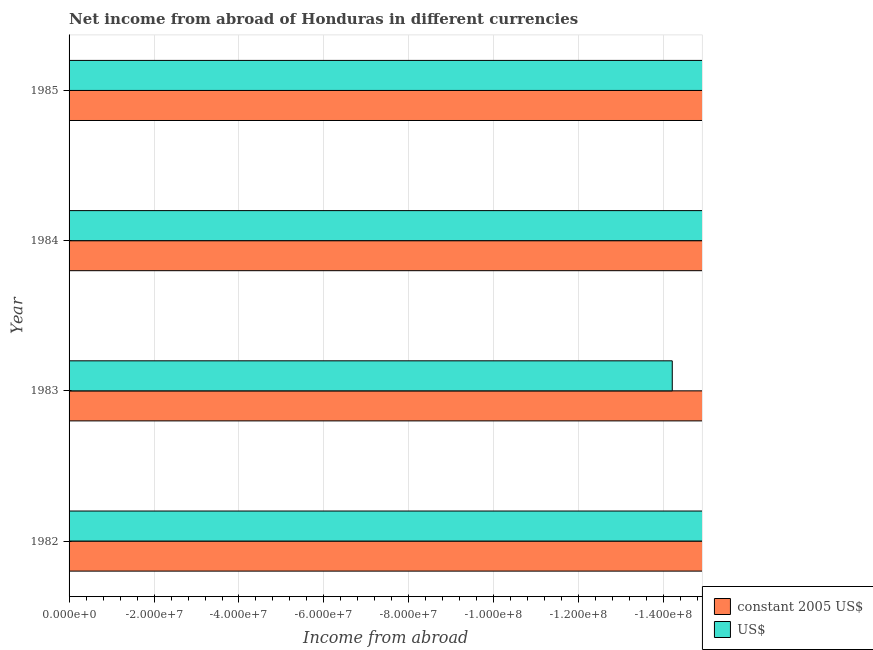How many different coloured bars are there?
Make the answer very short. 0. Are the number of bars per tick equal to the number of legend labels?
Make the answer very short. No. Are the number of bars on each tick of the Y-axis equal?
Give a very brief answer. Yes. How many bars are there on the 3rd tick from the top?
Keep it short and to the point. 0. How many bars are there on the 2nd tick from the bottom?
Give a very brief answer. 0. What is the total income from abroad in us$ in the graph?
Provide a short and direct response. 0. In how many years, is the income from abroad in us$ greater than the average income from abroad in us$ taken over all years?
Make the answer very short. 0. How many legend labels are there?
Ensure brevity in your answer.  2. What is the title of the graph?
Your response must be concise. Net income from abroad of Honduras in different currencies. Does "Secondary" appear as one of the legend labels in the graph?
Give a very brief answer. No. What is the label or title of the X-axis?
Ensure brevity in your answer.  Income from abroad. What is the label or title of the Y-axis?
Provide a short and direct response. Year. What is the Income from abroad in constant 2005 US$ in 1983?
Give a very brief answer. 0. What is the Income from abroad in US$ in 1983?
Your answer should be compact. 0. What is the Income from abroad in constant 2005 US$ in 1984?
Your response must be concise. 0. What is the Income from abroad of US$ in 1984?
Ensure brevity in your answer.  0. What is the total Income from abroad of constant 2005 US$ in the graph?
Provide a short and direct response. 0. 